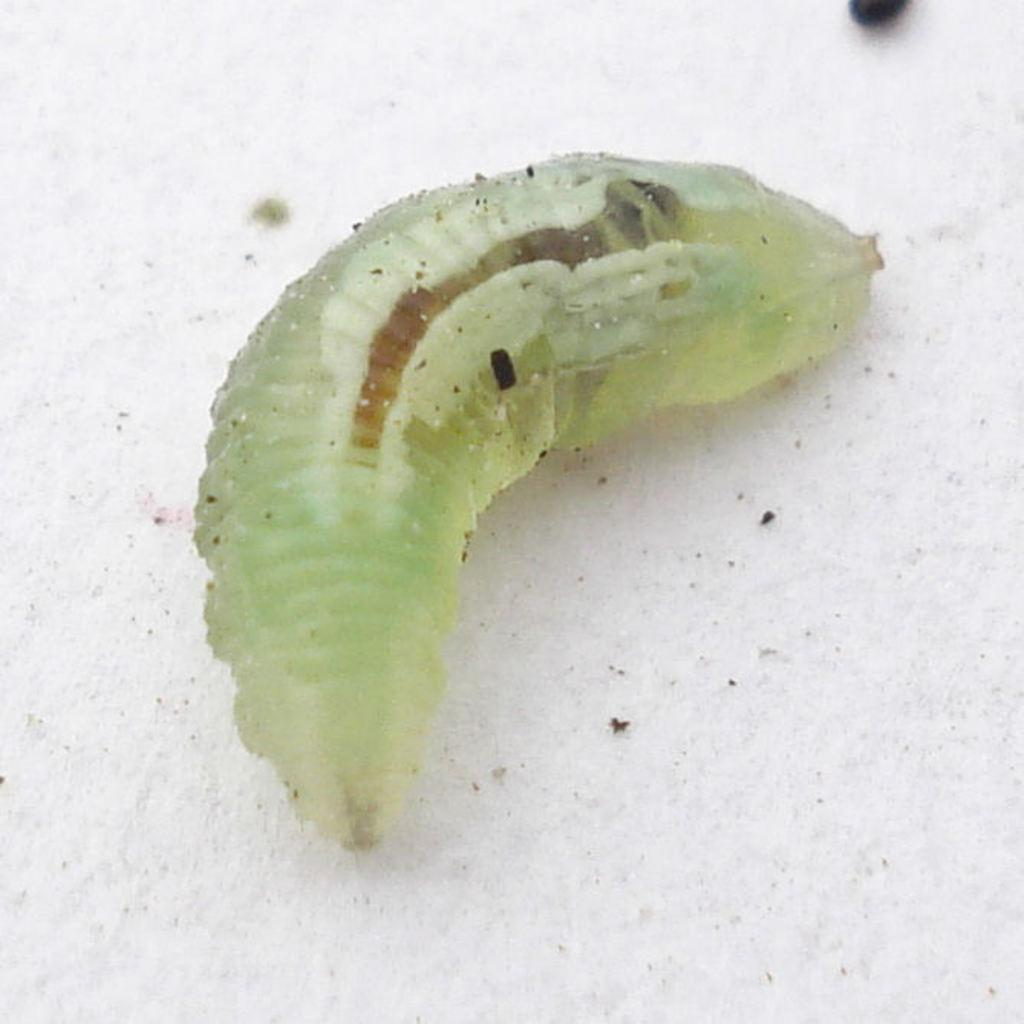What type of creature is present in the image? There is an insect in the image. Where is the insect located in the image? The insect is on the floor. What type of clam is crawling on the insect's knee in the image? There is no clam or any other creature interacting with the insect in the image. 